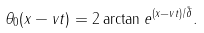<formula> <loc_0><loc_0><loc_500><loc_500>\theta _ { 0 } ( x - v t ) = 2 \arctan e ^ { ( x - v t ) / \tilde { \delta } } .</formula> 